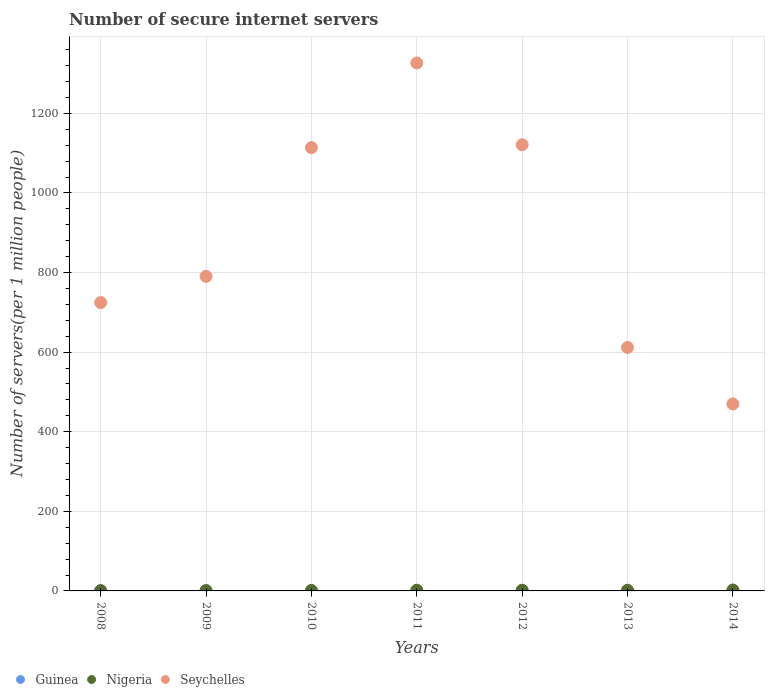How many different coloured dotlines are there?
Ensure brevity in your answer.  3. What is the number of secure internet servers in Nigeria in 2010?
Your response must be concise. 1.2. Across all years, what is the maximum number of secure internet servers in Guinea?
Your response must be concise. 0.44. Across all years, what is the minimum number of secure internet servers in Seychelles?
Your answer should be compact. 469.81. What is the total number of secure internet servers in Guinea in the graph?
Give a very brief answer. 1.93. What is the difference between the number of secure internet servers in Guinea in 2008 and that in 2014?
Provide a succinct answer. -0.23. What is the difference between the number of secure internet servers in Guinea in 2014 and the number of secure internet servers in Seychelles in 2008?
Provide a succinct answer. -724.18. What is the average number of secure internet servers in Nigeria per year?
Offer a very short reply. 1.46. In the year 2012, what is the difference between the number of secure internet servers in Nigeria and number of secure internet servers in Seychelles?
Make the answer very short. -1119.39. What is the ratio of the number of secure internet servers in Guinea in 2012 to that in 2013?
Make the answer very short. 5.14. What is the difference between the highest and the second highest number of secure internet servers in Guinea?
Give a very brief answer. 0.01. What is the difference between the highest and the lowest number of secure internet servers in Seychelles?
Provide a short and direct response. 856.8. In how many years, is the number of secure internet servers in Nigeria greater than the average number of secure internet servers in Nigeria taken over all years?
Offer a terse response. 4. Is the number of secure internet servers in Seychelles strictly greater than the number of secure internet servers in Nigeria over the years?
Your response must be concise. Yes. Is the number of secure internet servers in Guinea strictly less than the number of secure internet servers in Nigeria over the years?
Provide a succinct answer. Yes. Are the values on the major ticks of Y-axis written in scientific E-notation?
Make the answer very short. No. How many legend labels are there?
Ensure brevity in your answer.  3. How are the legend labels stacked?
Your response must be concise. Horizontal. What is the title of the graph?
Provide a succinct answer. Number of secure internet servers. What is the label or title of the X-axis?
Keep it short and to the point. Years. What is the label or title of the Y-axis?
Offer a terse response. Number of servers(per 1 million people). What is the Number of servers(per 1 million people) in Guinea in 2008?
Provide a succinct answer. 0.1. What is the Number of servers(per 1 million people) of Nigeria in 2008?
Your answer should be very brief. 0.79. What is the Number of servers(per 1 million people) of Seychelles in 2008?
Make the answer very short. 724.5. What is the Number of servers(per 1 million people) of Guinea in 2009?
Provide a short and direct response. 0.19. What is the Number of servers(per 1 million people) of Nigeria in 2009?
Ensure brevity in your answer.  0.81. What is the Number of servers(per 1 million people) of Seychelles in 2009?
Give a very brief answer. 790.4. What is the Number of servers(per 1 million people) of Guinea in 2010?
Your answer should be compact. 0.36. What is the Number of servers(per 1 million people) in Nigeria in 2010?
Make the answer very short. 1.2. What is the Number of servers(per 1 million people) of Seychelles in 2010?
Provide a succinct answer. 1113.96. What is the Number of servers(per 1 million people) in Guinea in 2011?
Give a very brief answer. 0.44. What is the Number of servers(per 1 million people) of Nigeria in 2011?
Your response must be concise. 1.68. What is the Number of servers(per 1 million people) in Seychelles in 2011?
Offer a very short reply. 1326.61. What is the Number of servers(per 1 million people) of Guinea in 2012?
Provide a short and direct response. 0.43. What is the Number of servers(per 1 million people) in Nigeria in 2012?
Give a very brief answer. 1.75. What is the Number of servers(per 1 million people) of Seychelles in 2012?
Make the answer very short. 1121.14. What is the Number of servers(per 1 million people) of Guinea in 2013?
Offer a terse response. 0.08. What is the Number of servers(per 1 million people) of Nigeria in 2013?
Your response must be concise. 1.68. What is the Number of servers(per 1 million people) in Seychelles in 2013?
Your answer should be very brief. 611.79. What is the Number of servers(per 1 million people) in Guinea in 2014?
Make the answer very short. 0.33. What is the Number of servers(per 1 million people) of Nigeria in 2014?
Provide a succinct answer. 2.32. What is the Number of servers(per 1 million people) of Seychelles in 2014?
Provide a succinct answer. 469.81. Across all years, what is the maximum Number of servers(per 1 million people) of Guinea?
Provide a short and direct response. 0.44. Across all years, what is the maximum Number of servers(per 1 million people) of Nigeria?
Your answer should be very brief. 2.32. Across all years, what is the maximum Number of servers(per 1 million people) of Seychelles?
Provide a short and direct response. 1326.61. Across all years, what is the minimum Number of servers(per 1 million people) in Guinea?
Keep it short and to the point. 0.08. Across all years, what is the minimum Number of servers(per 1 million people) in Nigeria?
Provide a succinct answer. 0.79. Across all years, what is the minimum Number of servers(per 1 million people) in Seychelles?
Your answer should be very brief. 469.81. What is the total Number of servers(per 1 million people) of Guinea in the graph?
Keep it short and to the point. 1.93. What is the total Number of servers(per 1 million people) of Nigeria in the graph?
Your response must be concise. 10.23. What is the total Number of servers(per 1 million people) of Seychelles in the graph?
Ensure brevity in your answer.  6158.21. What is the difference between the Number of servers(per 1 million people) in Guinea in 2008 and that in 2009?
Your response must be concise. -0.09. What is the difference between the Number of servers(per 1 million people) in Nigeria in 2008 and that in 2009?
Your answer should be compact. -0.01. What is the difference between the Number of servers(per 1 million people) in Seychelles in 2008 and that in 2009?
Ensure brevity in your answer.  -65.89. What is the difference between the Number of servers(per 1 million people) of Guinea in 2008 and that in 2010?
Your response must be concise. -0.27. What is the difference between the Number of servers(per 1 million people) in Nigeria in 2008 and that in 2010?
Your response must be concise. -0.4. What is the difference between the Number of servers(per 1 million people) in Seychelles in 2008 and that in 2010?
Keep it short and to the point. -389.45. What is the difference between the Number of servers(per 1 million people) in Guinea in 2008 and that in 2011?
Provide a short and direct response. -0.35. What is the difference between the Number of servers(per 1 million people) of Nigeria in 2008 and that in 2011?
Ensure brevity in your answer.  -0.89. What is the difference between the Number of servers(per 1 million people) in Seychelles in 2008 and that in 2011?
Your answer should be very brief. -602.1. What is the difference between the Number of servers(per 1 million people) in Guinea in 2008 and that in 2012?
Keep it short and to the point. -0.33. What is the difference between the Number of servers(per 1 million people) of Nigeria in 2008 and that in 2012?
Keep it short and to the point. -0.95. What is the difference between the Number of servers(per 1 million people) in Seychelles in 2008 and that in 2012?
Keep it short and to the point. -396.64. What is the difference between the Number of servers(per 1 million people) in Guinea in 2008 and that in 2013?
Your answer should be very brief. 0.01. What is the difference between the Number of servers(per 1 million people) in Nigeria in 2008 and that in 2013?
Offer a very short reply. -0.89. What is the difference between the Number of servers(per 1 million people) in Seychelles in 2008 and that in 2013?
Your answer should be very brief. 112.71. What is the difference between the Number of servers(per 1 million people) in Guinea in 2008 and that in 2014?
Provide a succinct answer. -0.23. What is the difference between the Number of servers(per 1 million people) of Nigeria in 2008 and that in 2014?
Give a very brief answer. -1.53. What is the difference between the Number of servers(per 1 million people) in Seychelles in 2008 and that in 2014?
Your answer should be compact. 254.69. What is the difference between the Number of servers(per 1 million people) of Guinea in 2009 and that in 2010?
Offer a very short reply. -0.18. What is the difference between the Number of servers(per 1 million people) in Nigeria in 2009 and that in 2010?
Provide a short and direct response. -0.39. What is the difference between the Number of servers(per 1 million people) of Seychelles in 2009 and that in 2010?
Ensure brevity in your answer.  -323.56. What is the difference between the Number of servers(per 1 million people) in Guinea in 2009 and that in 2011?
Offer a terse response. -0.26. What is the difference between the Number of servers(per 1 million people) in Nigeria in 2009 and that in 2011?
Give a very brief answer. -0.87. What is the difference between the Number of servers(per 1 million people) in Seychelles in 2009 and that in 2011?
Ensure brevity in your answer.  -536.21. What is the difference between the Number of servers(per 1 million people) of Guinea in 2009 and that in 2012?
Give a very brief answer. -0.24. What is the difference between the Number of servers(per 1 million people) of Nigeria in 2009 and that in 2012?
Make the answer very short. -0.94. What is the difference between the Number of servers(per 1 million people) of Seychelles in 2009 and that in 2012?
Your answer should be very brief. -330.74. What is the difference between the Number of servers(per 1 million people) of Guinea in 2009 and that in 2013?
Keep it short and to the point. 0.1. What is the difference between the Number of servers(per 1 million people) of Nigeria in 2009 and that in 2013?
Ensure brevity in your answer.  -0.88. What is the difference between the Number of servers(per 1 million people) in Seychelles in 2009 and that in 2013?
Keep it short and to the point. 178.61. What is the difference between the Number of servers(per 1 million people) of Guinea in 2009 and that in 2014?
Provide a succinct answer. -0.14. What is the difference between the Number of servers(per 1 million people) of Nigeria in 2009 and that in 2014?
Your answer should be very brief. -1.52. What is the difference between the Number of servers(per 1 million people) of Seychelles in 2009 and that in 2014?
Keep it short and to the point. 320.58. What is the difference between the Number of servers(per 1 million people) in Guinea in 2010 and that in 2011?
Your answer should be compact. -0.08. What is the difference between the Number of servers(per 1 million people) of Nigeria in 2010 and that in 2011?
Keep it short and to the point. -0.48. What is the difference between the Number of servers(per 1 million people) in Seychelles in 2010 and that in 2011?
Your answer should be compact. -212.65. What is the difference between the Number of servers(per 1 million people) of Guinea in 2010 and that in 2012?
Offer a very short reply. -0.07. What is the difference between the Number of servers(per 1 million people) in Nigeria in 2010 and that in 2012?
Your answer should be very brief. -0.55. What is the difference between the Number of servers(per 1 million people) of Seychelles in 2010 and that in 2012?
Provide a short and direct response. -7.18. What is the difference between the Number of servers(per 1 million people) of Guinea in 2010 and that in 2013?
Offer a very short reply. 0.28. What is the difference between the Number of servers(per 1 million people) in Nigeria in 2010 and that in 2013?
Give a very brief answer. -0.49. What is the difference between the Number of servers(per 1 million people) in Seychelles in 2010 and that in 2013?
Provide a short and direct response. 502.17. What is the difference between the Number of servers(per 1 million people) of Guinea in 2010 and that in 2014?
Your answer should be very brief. 0.04. What is the difference between the Number of servers(per 1 million people) of Nigeria in 2010 and that in 2014?
Keep it short and to the point. -1.12. What is the difference between the Number of servers(per 1 million people) in Seychelles in 2010 and that in 2014?
Your answer should be compact. 644.15. What is the difference between the Number of servers(per 1 million people) in Guinea in 2011 and that in 2012?
Make the answer very short. 0.01. What is the difference between the Number of servers(per 1 million people) of Nigeria in 2011 and that in 2012?
Keep it short and to the point. -0.07. What is the difference between the Number of servers(per 1 million people) in Seychelles in 2011 and that in 2012?
Make the answer very short. 205.47. What is the difference between the Number of servers(per 1 million people) in Guinea in 2011 and that in 2013?
Provide a succinct answer. 0.36. What is the difference between the Number of servers(per 1 million people) of Nigeria in 2011 and that in 2013?
Your response must be concise. -0. What is the difference between the Number of servers(per 1 million people) of Seychelles in 2011 and that in 2013?
Provide a short and direct response. 714.82. What is the difference between the Number of servers(per 1 million people) in Guinea in 2011 and that in 2014?
Give a very brief answer. 0.12. What is the difference between the Number of servers(per 1 million people) in Nigeria in 2011 and that in 2014?
Make the answer very short. -0.64. What is the difference between the Number of servers(per 1 million people) of Seychelles in 2011 and that in 2014?
Offer a very short reply. 856.8. What is the difference between the Number of servers(per 1 million people) of Guinea in 2012 and that in 2013?
Provide a short and direct response. 0.35. What is the difference between the Number of servers(per 1 million people) of Nigeria in 2012 and that in 2013?
Offer a very short reply. 0.06. What is the difference between the Number of servers(per 1 million people) in Seychelles in 2012 and that in 2013?
Make the answer very short. 509.35. What is the difference between the Number of servers(per 1 million people) in Guinea in 2012 and that in 2014?
Your response must be concise. 0.1. What is the difference between the Number of servers(per 1 million people) of Nigeria in 2012 and that in 2014?
Your answer should be compact. -0.57. What is the difference between the Number of servers(per 1 million people) in Seychelles in 2012 and that in 2014?
Provide a short and direct response. 651.33. What is the difference between the Number of servers(per 1 million people) of Guinea in 2013 and that in 2014?
Your answer should be compact. -0.24. What is the difference between the Number of servers(per 1 million people) of Nigeria in 2013 and that in 2014?
Offer a terse response. -0.64. What is the difference between the Number of servers(per 1 million people) in Seychelles in 2013 and that in 2014?
Your response must be concise. 141.98. What is the difference between the Number of servers(per 1 million people) of Guinea in 2008 and the Number of servers(per 1 million people) of Nigeria in 2009?
Offer a very short reply. -0.71. What is the difference between the Number of servers(per 1 million people) of Guinea in 2008 and the Number of servers(per 1 million people) of Seychelles in 2009?
Ensure brevity in your answer.  -790.3. What is the difference between the Number of servers(per 1 million people) in Nigeria in 2008 and the Number of servers(per 1 million people) in Seychelles in 2009?
Offer a terse response. -789.6. What is the difference between the Number of servers(per 1 million people) in Guinea in 2008 and the Number of servers(per 1 million people) in Nigeria in 2010?
Offer a very short reply. -1.1. What is the difference between the Number of servers(per 1 million people) of Guinea in 2008 and the Number of servers(per 1 million people) of Seychelles in 2010?
Your answer should be very brief. -1113.86. What is the difference between the Number of servers(per 1 million people) of Nigeria in 2008 and the Number of servers(per 1 million people) of Seychelles in 2010?
Make the answer very short. -1113.16. What is the difference between the Number of servers(per 1 million people) of Guinea in 2008 and the Number of servers(per 1 million people) of Nigeria in 2011?
Your answer should be compact. -1.58. What is the difference between the Number of servers(per 1 million people) in Guinea in 2008 and the Number of servers(per 1 million people) in Seychelles in 2011?
Keep it short and to the point. -1326.51. What is the difference between the Number of servers(per 1 million people) in Nigeria in 2008 and the Number of servers(per 1 million people) in Seychelles in 2011?
Ensure brevity in your answer.  -1325.81. What is the difference between the Number of servers(per 1 million people) of Guinea in 2008 and the Number of servers(per 1 million people) of Nigeria in 2012?
Give a very brief answer. -1.65. What is the difference between the Number of servers(per 1 million people) of Guinea in 2008 and the Number of servers(per 1 million people) of Seychelles in 2012?
Offer a very short reply. -1121.04. What is the difference between the Number of servers(per 1 million people) of Nigeria in 2008 and the Number of servers(per 1 million people) of Seychelles in 2012?
Give a very brief answer. -1120.35. What is the difference between the Number of servers(per 1 million people) in Guinea in 2008 and the Number of servers(per 1 million people) in Nigeria in 2013?
Ensure brevity in your answer.  -1.59. What is the difference between the Number of servers(per 1 million people) in Guinea in 2008 and the Number of servers(per 1 million people) in Seychelles in 2013?
Your answer should be compact. -611.7. What is the difference between the Number of servers(per 1 million people) of Nigeria in 2008 and the Number of servers(per 1 million people) of Seychelles in 2013?
Provide a succinct answer. -611. What is the difference between the Number of servers(per 1 million people) of Guinea in 2008 and the Number of servers(per 1 million people) of Nigeria in 2014?
Offer a terse response. -2.23. What is the difference between the Number of servers(per 1 million people) in Guinea in 2008 and the Number of servers(per 1 million people) in Seychelles in 2014?
Give a very brief answer. -469.72. What is the difference between the Number of servers(per 1 million people) in Nigeria in 2008 and the Number of servers(per 1 million people) in Seychelles in 2014?
Keep it short and to the point. -469.02. What is the difference between the Number of servers(per 1 million people) in Guinea in 2009 and the Number of servers(per 1 million people) in Nigeria in 2010?
Your answer should be very brief. -1.01. What is the difference between the Number of servers(per 1 million people) in Guinea in 2009 and the Number of servers(per 1 million people) in Seychelles in 2010?
Give a very brief answer. -1113.77. What is the difference between the Number of servers(per 1 million people) of Nigeria in 2009 and the Number of servers(per 1 million people) of Seychelles in 2010?
Offer a terse response. -1113.15. What is the difference between the Number of servers(per 1 million people) of Guinea in 2009 and the Number of servers(per 1 million people) of Nigeria in 2011?
Offer a terse response. -1.49. What is the difference between the Number of servers(per 1 million people) of Guinea in 2009 and the Number of servers(per 1 million people) of Seychelles in 2011?
Your answer should be very brief. -1326.42. What is the difference between the Number of servers(per 1 million people) in Nigeria in 2009 and the Number of servers(per 1 million people) in Seychelles in 2011?
Make the answer very short. -1325.8. What is the difference between the Number of servers(per 1 million people) in Guinea in 2009 and the Number of servers(per 1 million people) in Nigeria in 2012?
Offer a very short reply. -1.56. What is the difference between the Number of servers(per 1 million people) of Guinea in 2009 and the Number of servers(per 1 million people) of Seychelles in 2012?
Provide a short and direct response. -1120.95. What is the difference between the Number of servers(per 1 million people) of Nigeria in 2009 and the Number of servers(per 1 million people) of Seychelles in 2012?
Your answer should be compact. -1120.33. What is the difference between the Number of servers(per 1 million people) of Guinea in 2009 and the Number of servers(per 1 million people) of Nigeria in 2013?
Provide a short and direct response. -1.5. What is the difference between the Number of servers(per 1 million people) of Guinea in 2009 and the Number of servers(per 1 million people) of Seychelles in 2013?
Offer a terse response. -611.6. What is the difference between the Number of servers(per 1 million people) of Nigeria in 2009 and the Number of servers(per 1 million people) of Seychelles in 2013?
Your answer should be compact. -610.99. What is the difference between the Number of servers(per 1 million people) in Guinea in 2009 and the Number of servers(per 1 million people) in Nigeria in 2014?
Offer a very short reply. -2.13. What is the difference between the Number of servers(per 1 million people) in Guinea in 2009 and the Number of servers(per 1 million people) in Seychelles in 2014?
Provide a succinct answer. -469.63. What is the difference between the Number of servers(per 1 million people) of Nigeria in 2009 and the Number of servers(per 1 million people) of Seychelles in 2014?
Provide a succinct answer. -469.01. What is the difference between the Number of servers(per 1 million people) in Guinea in 2010 and the Number of servers(per 1 million people) in Nigeria in 2011?
Your answer should be compact. -1.32. What is the difference between the Number of servers(per 1 million people) in Guinea in 2010 and the Number of servers(per 1 million people) in Seychelles in 2011?
Provide a succinct answer. -1326.25. What is the difference between the Number of servers(per 1 million people) in Nigeria in 2010 and the Number of servers(per 1 million people) in Seychelles in 2011?
Make the answer very short. -1325.41. What is the difference between the Number of servers(per 1 million people) in Guinea in 2010 and the Number of servers(per 1 million people) in Nigeria in 2012?
Your response must be concise. -1.38. What is the difference between the Number of servers(per 1 million people) in Guinea in 2010 and the Number of servers(per 1 million people) in Seychelles in 2012?
Offer a terse response. -1120.78. What is the difference between the Number of servers(per 1 million people) of Nigeria in 2010 and the Number of servers(per 1 million people) of Seychelles in 2012?
Offer a terse response. -1119.94. What is the difference between the Number of servers(per 1 million people) of Guinea in 2010 and the Number of servers(per 1 million people) of Nigeria in 2013?
Ensure brevity in your answer.  -1.32. What is the difference between the Number of servers(per 1 million people) in Guinea in 2010 and the Number of servers(per 1 million people) in Seychelles in 2013?
Provide a short and direct response. -611.43. What is the difference between the Number of servers(per 1 million people) of Nigeria in 2010 and the Number of servers(per 1 million people) of Seychelles in 2013?
Provide a short and direct response. -610.59. What is the difference between the Number of servers(per 1 million people) of Guinea in 2010 and the Number of servers(per 1 million people) of Nigeria in 2014?
Offer a very short reply. -1.96. What is the difference between the Number of servers(per 1 million people) of Guinea in 2010 and the Number of servers(per 1 million people) of Seychelles in 2014?
Keep it short and to the point. -469.45. What is the difference between the Number of servers(per 1 million people) of Nigeria in 2010 and the Number of servers(per 1 million people) of Seychelles in 2014?
Your answer should be compact. -468.61. What is the difference between the Number of servers(per 1 million people) of Guinea in 2011 and the Number of servers(per 1 million people) of Nigeria in 2012?
Ensure brevity in your answer.  -1.31. What is the difference between the Number of servers(per 1 million people) of Guinea in 2011 and the Number of servers(per 1 million people) of Seychelles in 2012?
Your response must be concise. -1120.7. What is the difference between the Number of servers(per 1 million people) of Nigeria in 2011 and the Number of servers(per 1 million people) of Seychelles in 2012?
Offer a very short reply. -1119.46. What is the difference between the Number of servers(per 1 million people) of Guinea in 2011 and the Number of servers(per 1 million people) of Nigeria in 2013?
Keep it short and to the point. -1.24. What is the difference between the Number of servers(per 1 million people) in Guinea in 2011 and the Number of servers(per 1 million people) in Seychelles in 2013?
Provide a short and direct response. -611.35. What is the difference between the Number of servers(per 1 million people) in Nigeria in 2011 and the Number of servers(per 1 million people) in Seychelles in 2013?
Give a very brief answer. -610.11. What is the difference between the Number of servers(per 1 million people) in Guinea in 2011 and the Number of servers(per 1 million people) in Nigeria in 2014?
Keep it short and to the point. -1.88. What is the difference between the Number of servers(per 1 million people) in Guinea in 2011 and the Number of servers(per 1 million people) in Seychelles in 2014?
Give a very brief answer. -469.37. What is the difference between the Number of servers(per 1 million people) in Nigeria in 2011 and the Number of servers(per 1 million people) in Seychelles in 2014?
Provide a short and direct response. -468.13. What is the difference between the Number of servers(per 1 million people) in Guinea in 2012 and the Number of servers(per 1 million people) in Nigeria in 2013?
Make the answer very short. -1.25. What is the difference between the Number of servers(per 1 million people) of Guinea in 2012 and the Number of servers(per 1 million people) of Seychelles in 2013?
Provide a succinct answer. -611.36. What is the difference between the Number of servers(per 1 million people) in Nigeria in 2012 and the Number of servers(per 1 million people) in Seychelles in 2013?
Provide a short and direct response. -610.04. What is the difference between the Number of servers(per 1 million people) of Guinea in 2012 and the Number of servers(per 1 million people) of Nigeria in 2014?
Your answer should be very brief. -1.89. What is the difference between the Number of servers(per 1 million people) in Guinea in 2012 and the Number of servers(per 1 million people) in Seychelles in 2014?
Provide a short and direct response. -469.38. What is the difference between the Number of servers(per 1 million people) in Nigeria in 2012 and the Number of servers(per 1 million people) in Seychelles in 2014?
Your answer should be very brief. -468.06. What is the difference between the Number of servers(per 1 million people) of Guinea in 2013 and the Number of servers(per 1 million people) of Nigeria in 2014?
Offer a terse response. -2.24. What is the difference between the Number of servers(per 1 million people) in Guinea in 2013 and the Number of servers(per 1 million people) in Seychelles in 2014?
Your answer should be compact. -469.73. What is the difference between the Number of servers(per 1 million people) of Nigeria in 2013 and the Number of servers(per 1 million people) of Seychelles in 2014?
Your response must be concise. -468.13. What is the average Number of servers(per 1 million people) in Guinea per year?
Your answer should be very brief. 0.28. What is the average Number of servers(per 1 million people) in Nigeria per year?
Give a very brief answer. 1.46. What is the average Number of servers(per 1 million people) in Seychelles per year?
Your response must be concise. 879.74. In the year 2008, what is the difference between the Number of servers(per 1 million people) of Guinea and Number of servers(per 1 million people) of Nigeria?
Provide a succinct answer. -0.7. In the year 2008, what is the difference between the Number of servers(per 1 million people) of Guinea and Number of servers(per 1 million people) of Seychelles?
Your response must be concise. -724.41. In the year 2008, what is the difference between the Number of servers(per 1 million people) in Nigeria and Number of servers(per 1 million people) in Seychelles?
Your answer should be very brief. -723.71. In the year 2009, what is the difference between the Number of servers(per 1 million people) in Guinea and Number of servers(per 1 million people) in Nigeria?
Your answer should be compact. -0.62. In the year 2009, what is the difference between the Number of servers(per 1 million people) of Guinea and Number of servers(per 1 million people) of Seychelles?
Your answer should be very brief. -790.21. In the year 2009, what is the difference between the Number of servers(per 1 million people) of Nigeria and Number of servers(per 1 million people) of Seychelles?
Your answer should be compact. -789.59. In the year 2010, what is the difference between the Number of servers(per 1 million people) in Guinea and Number of servers(per 1 million people) in Nigeria?
Your answer should be compact. -0.83. In the year 2010, what is the difference between the Number of servers(per 1 million people) of Guinea and Number of servers(per 1 million people) of Seychelles?
Your answer should be compact. -1113.59. In the year 2010, what is the difference between the Number of servers(per 1 million people) in Nigeria and Number of servers(per 1 million people) in Seychelles?
Offer a terse response. -1112.76. In the year 2011, what is the difference between the Number of servers(per 1 million people) in Guinea and Number of servers(per 1 million people) in Nigeria?
Ensure brevity in your answer.  -1.24. In the year 2011, what is the difference between the Number of servers(per 1 million people) in Guinea and Number of servers(per 1 million people) in Seychelles?
Your answer should be very brief. -1326.17. In the year 2011, what is the difference between the Number of servers(per 1 million people) of Nigeria and Number of servers(per 1 million people) of Seychelles?
Your response must be concise. -1324.93. In the year 2012, what is the difference between the Number of servers(per 1 million people) in Guinea and Number of servers(per 1 million people) in Nigeria?
Your answer should be compact. -1.32. In the year 2012, what is the difference between the Number of servers(per 1 million people) in Guinea and Number of servers(per 1 million people) in Seychelles?
Offer a very short reply. -1120.71. In the year 2012, what is the difference between the Number of servers(per 1 million people) in Nigeria and Number of servers(per 1 million people) in Seychelles?
Keep it short and to the point. -1119.39. In the year 2013, what is the difference between the Number of servers(per 1 million people) of Guinea and Number of servers(per 1 million people) of Nigeria?
Provide a short and direct response. -1.6. In the year 2013, what is the difference between the Number of servers(per 1 million people) of Guinea and Number of servers(per 1 million people) of Seychelles?
Make the answer very short. -611.71. In the year 2013, what is the difference between the Number of servers(per 1 million people) in Nigeria and Number of servers(per 1 million people) in Seychelles?
Ensure brevity in your answer.  -610.11. In the year 2014, what is the difference between the Number of servers(per 1 million people) in Guinea and Number of servers(per 1 million people) in Nigeria?
Provide a short and direct response. -2. In the year 2014, what is the difference between the Number of servers(per 1 million people) in Guinea and Number of servers(per 1 million people) in Seychelles?
Give a very brief answer. -469.49. In the year 2014, what is the difference between the Number of servers(per 1 million people) in Nigeria and Number of servers(per 1 million people) in Seychelles?
Offer a terse response. -467.49. What is the ratio of the Number of servers(per 1 million people) in Guinea in 2008 to that in 2009?
Provide a short and direct response. 0.51. What is the ratio of the Number of servers(per 1 million people) in Nigeria in 2008 to that in 2009?
Offer a very short reply. 0.99. What is the ratio of the Number of servers(per 1 million people) in Seychelles in 2008 to that in 2009?
Provide a short and direct response. 0.92. What is the ratio of the Number of servers(per 1 million people) of Guinea in 2008 to that in 2010?
Provide a short and direct response. 0.26. What is the ratio of the Number of servers(per 1 million people) in Nigeria in 2008 to that in 2010?
Offer a very short reply. 0.66. What is the ratio of the Number of servers(per 1 million people) in Seychelles in 2008 to that in 2010?
Your answer should be compact. 0.65. What is the ratio of the Number of servers(per 1 million people) of Guinea in 2008 to that in 2011?
Your response must be concise. 0.22. What is the ratio of the Number of servers(per 1 million people) in Nigeria in 2008 to that in 2011?
Provide a succinct answer. 0.47. What is the ratio of the Number of servers(per 1 million people) of Seychelles in 2008 to that in 2011?
Provide a succinct answer. 0.55. What is the ratio of the Number of servers(per 1 million people) in Guinea in 2008 to that in 2012?
Offer a very short reply. 0.22. What is the ratio of the Number of servers(per 1 million people) of Nigeria in 2008 to that in 2012?
Your answer should be very brief. 0.45. What is the ratio of the Number of servers(per 1 million people) in Seychelles in 2008 to that in 2012?
Make the answer very short. 0.65. What is the ratio of the Number of servers(per 1 million people) of Guinea in 2008 to that in 2013?
Give a very brief answer. 1.15. What is the ratio of the Number of servers(per 1 million people) of Nigeria in 2008 to that in 2013?
Offer a very short reply. 0.47. What is the ratio of the Number of servers(per 1 million people) of Seychelles in 2008 to that in 2013?
Make the answer very short. 1.18. What is the ratio of the Number of servers(per 1 million people) of Guinea in 2008 to that in 2014?
Offer a terse response. 0.29. What is the ratio of the Number of servers(per 1 million people) in Nigeria in 2008 to that in 2014?
Your answer should be very brief. 0.34. What is the ratio of the Number of servers(per 1 million people) of Seychelles in 2008 to that in 2014?
Your response must be concise. 1.54. What is the ratio of the Number of servers(per 1 million people) of Guinea in 2009 to that in 2010?
Your answer should be compact. 0.51. What is the ratio of the Number of servers(per 1 million people) in Nigeria in 2009 to that in 2010?
Make the answer very short. 0.67. What is the ratio of the Number of servers(per 1 million people) of Seychelles in 2009 to that in 2010?
Give a very brief answer. 0.71. What is the ratio of the Number of servers(per 1 million people) in Guinea in 2009 to that in 2011?
Offer a terse response. 0.42. What is the ratio of the Number of servers(per 1 million people) in Nigeria in 2009 to that in 2011?
Make the answer very short. 0.48. What is the ratio of the Number of servers(per 1 million people) in Seychelles in 2009 to that in 2011?
Your answer should be very brief. 0.6. What is the ratio of the Number of servers(per 1 million people) of Guinea in 2009 to that in 2012?
Your answer should be very brief. 0.43. What is the ratio of the Number of servers(per 1 million people) in Nigeria in 2009 to that in 2012?
Your answer should be very brief. 0.46. What is the ratio of the Number of servers(per 1 million people) of Seychelles in 2009 to that in 2012?
Offer a very short reply. 0.7. What is the ratio of the Number of servers(per 1 million people) in Guinea in 2009 to that in 2013?
Ensure brevity in your answer.  2.23. What is the ratio of the Number of servers(per 1 million people) of Nigeria in 2009 to that in 2013?
Provide a short and direct response. 0.48. What is the ratio of the Number of servers(per 1 million people) in Seychelles in 2009 to that in 2013?
Make the answer very short. 1.29. What is the ratio of the Number of servers(per 1 million people) in Guinea in 2009 to that in 2014?
Provide a succinct answer. 0.57. What is the ratio of the Number of servers(per 1 million people) in Nigeria in 2009 to that in 2014?
Keep it short and to the point. 0.35. What is the ratio of the Number of servers(per 1 million people) in Seychelles in 2009 to that in 2014?
Offer a terse response. 1.68. What is the ratio of the Number of servers(per 1 million people) in Guinea in 2010 to that in 2011?
Give a very brief answer. 0.82. What is the ratio of the Number of servers(per 1 million people) in Nigeria in 2010 to that in 2011?
Your answer should be compact. 0.71. What is the ratio of the Number of servers(per 1 million people) of Seychelles in 2010 to that in 2011?
Keep it short and to the point. 0.84. What is the ratio of the Number of servers(per 1 million people) of Guinea in 2010 to that in 2012?
Provide a succinct answer. 0.84. What is the ratio of the Number of servers(per 1 million people) of Nigeria in 2010 to that in 2012?
Your answer should be compact. 0.69. What is the ratio of the Number of servers(per 1 million people) of Guinea in 2010 to that in 2013?
Provide a short and direct response. 4.34. What is the ratio of the Number of servers(per 1 million people) of Nigeria in 2010 to that in 2013?
Your response must be concise. 0.71. What is the ratio of the Number of servers(per 1 million people) in Seychelles in 2010 to that in 2013?
Your answer should be very brief. 1.82. What is the ratio of the Number of servers(per 1 million people) of Guinea in 2010 to that in 2014?
Make the answer very short. 1.11. What is the ratio of the Number of servers(per 1 million people) in Nigeria in 2010 to that in 2014?
Make the answer very short. 0.52. What is the ratio of the Number of servers(per 1 million people) of Seychelles in 2010 to that in 2014?
Offer a very short reply. 2.37. What is the ratio of the Number of servers(per 1 million people) of Guinea in 2011 to that in 2012?
Offer a terse response. 1.03. What is the ratio of the Number of servers(per 1 million people) of Nigeria in 2011 to that in 2012?
Your answer should be very brief. 0.96. What is the ratio of the Number of servers(per 1 million people) in Seychelles in 2011 to that in 2012?
Keep it short and to the point. 1.18. What is the ratio of the Number of servers(per 1 million people) in Guinea in 2011 to that in 2013?
Keep it short and to the point. 5.28. What is the ratio of the Number of servers(per 1 million people) of Nigeria in 2011 to that in 2013?
Your response must be concise. 1. What is the ratio of the Number of servers(per 1 million people) of Seychelles in 2011 to that in 2013?
Make the answer very short. 2.17. What is the ratio of the Number of servers(per 1 million people) in Guinea in 2011 to that in 2014?
Ensure brevity in your answer.  1.36. What is the ratio of the Number of servers(per 1 million people) of Nigeria in 2011 to that in 2014?
Your response must be concise. 0.72. What is the ratio of the Number of servers(per 1 million people) of Seychelles in 2011 to that in 2014?
Your answer should be very brief. 2.82. What is the ratio of the Number of servers(per 1 million people) of Guinea in 2012 to that in 2013?
Your answer should be very brief. 5.14. What is the ratio of the Number of servers(per 1 million people) in Nigeria in 2012 to that in 2013?
Make the answer very short. 1.04. What is the ratio of the Number of servers(per 1 million people) of Seychelles in 2012 to that in 2013?
Provide a short and direct response. 1.83. What is the ratio of the Number of servers(per 1 million people) in Guinea in 2012 to that in 2014?
Offer a very short reply. 1.32. What is the ratio of the Number of servers(per 1 million people) in Nigeria in 2012 to that in 2014?
Offer a terse response. 0.75. What is the ratio of the Number of servers(per 1 million people) of Seychelles in 2012 to that in 2014?
Ensure brevity in your answer.  2.39. What is the ratio of the Number of servers(per 1 million people) in Guinea in 2013 to that in 2014?
Provide a succinct answer. 0.26. What is the ratio of the Number of servers(per 1 million people) in Nigeria in 2013 to that in 2014?
Make the answer very short. 0.73. What is the ratio of the Number of servers(per 1 million people) in Seychelles in 2013 to that in 2014?
Ensure brevity in your answer.  1.3. What is the difference between the highest and the second highest Number of servers(per 1 million people) in Guinea?
Offer a very short reply. 0.01. What is the difference between the highest and the second highest Number of servers(per 1 million people) of Nigeria?
Ensure brevity in your answer.  0.57. What is the difference between the highest and the second highest Number of servers(per 1 million people) of Seychelles?
Provide a short and direct response. 205.47. What is the difference between the highest and the lowest Number of servers(per 1 million people) in Guinea?
Provide a succinct answer. 0.36. What is the difference between the highest and the lowest Number of servers(per 1 million people) of Nigeria?
Keep it short and to the point. 1.53. What is the difference between the highest and the lowest Number of servers(per 1 million people) in Seychelles?
Your answer should be very brief. 856.8. 